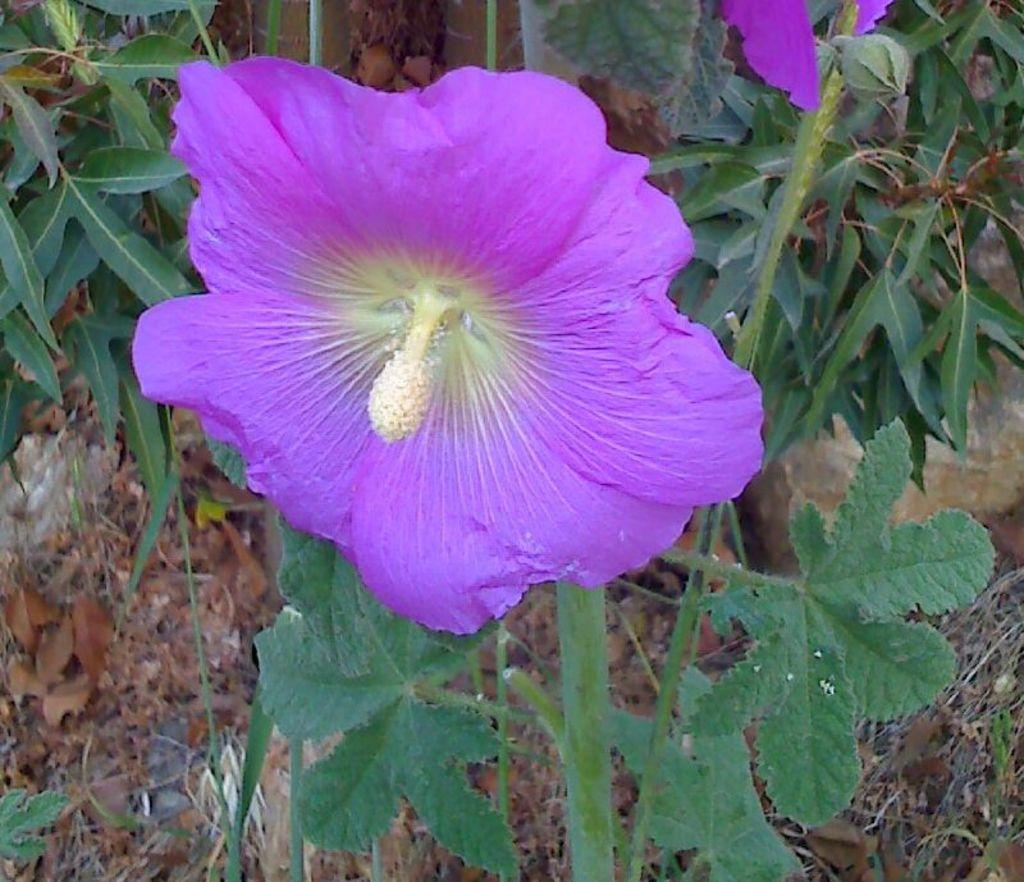What is the main subject of the image? There is a flower in the image. What can be seen in the background of the image? There are leaves in the background of the image. What type of vegetation is on the ground in the image? There are dried leaves on the ground in the image. What type of wine is being served at the place in the image? There is no place or wine present in the image; it features a flower, leaves, and dried leaves. 